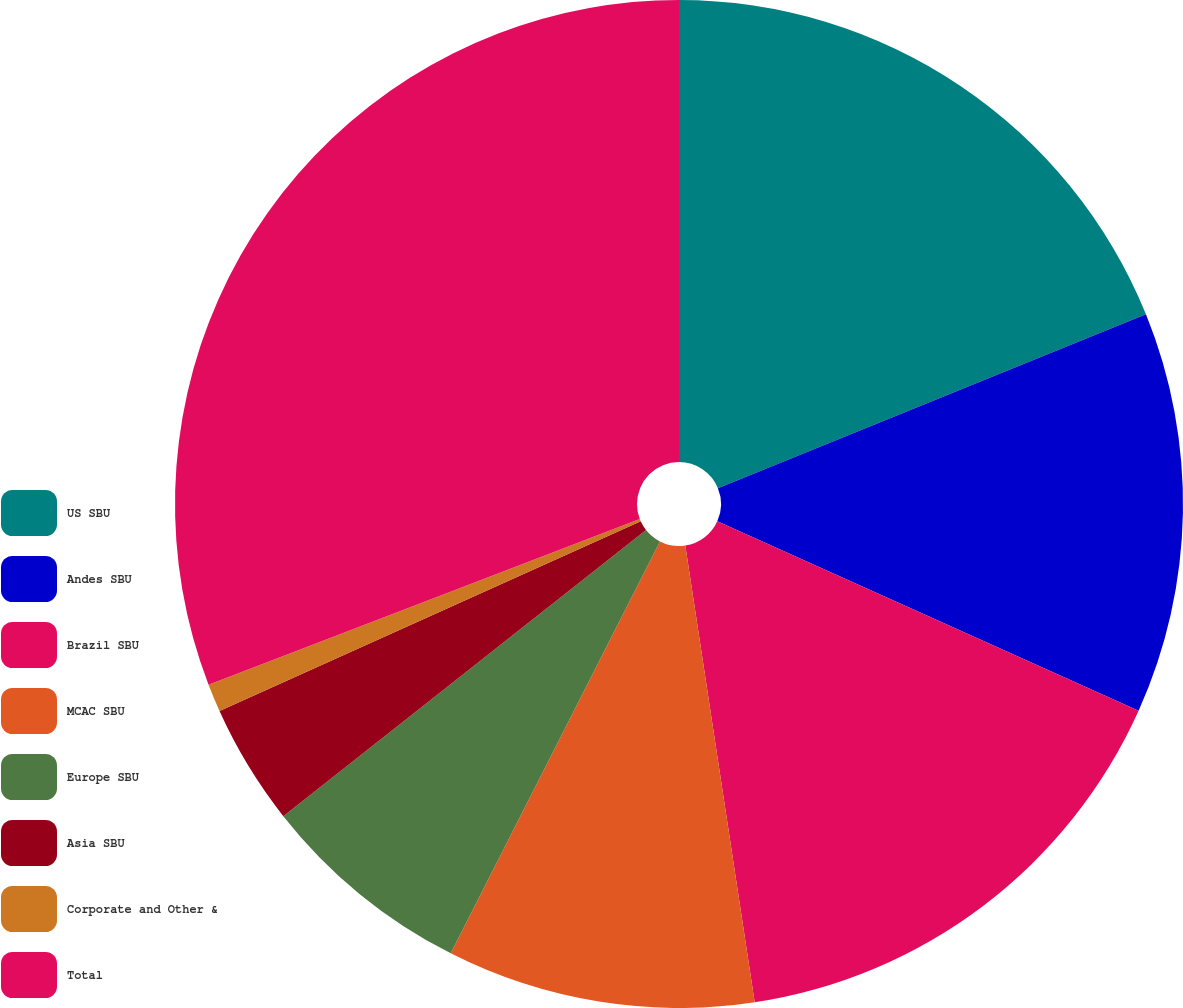Convert chart to OTSL. <chart><loc_0><loc_0><loc_500><loc_500><pie_chart><fcel>US SBU<fcel>Andes SBU<fcel>Brazil SBU<fcel>MCAC SBU<fcel>Europe SBU<fcel>Asia SBU<fcel>Corporate and Other &<fcel>Total<nl><fcel>18.86%<fcel>12.87%<fcel>15.87%<fcel>9.88%<fcel>6.89%<fcel>3.89%<fcel>0.9%<fcel>30.84%<nl></chart> 